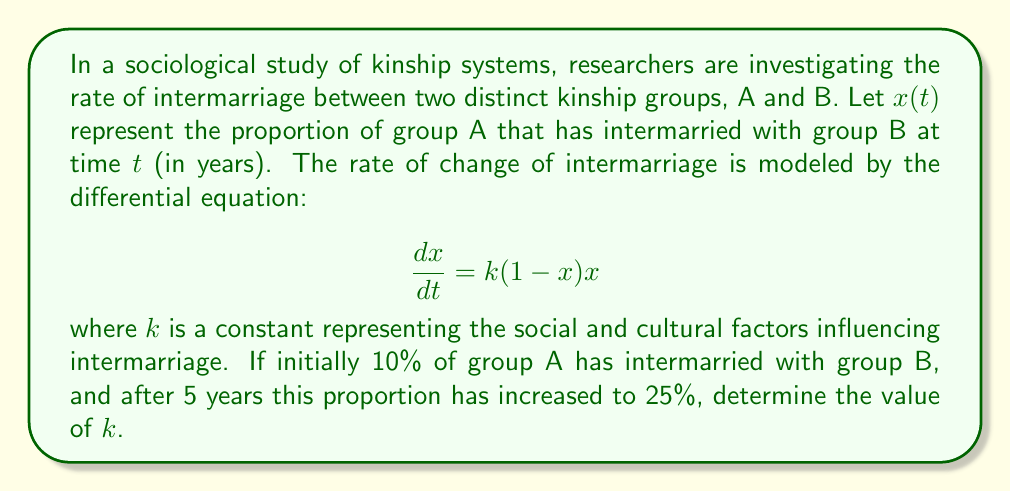Help me with this question. To solve this problem, we need to follow these steps:

1) First, we recognize this as a separable first-order differential equation.

2) We can separate the variables and integrate both sides:

   $$\int \frac{dx}{(1-x)x} = \int k dt$$

3) The left side can be integrated using partial fractions:

   $$\int (\frac{1}{x} + \frac{1}{1-x}) dx = kt + C$$

4) Integrating, we get:

   $$\ln|\frac{x}{1-x}| = kt + C$$

5) We can write this in the form of a logistic function:

   $$x = \frac{1}{1 + Ae^{-kt}}$$

   where $A$ is a constant.

6) Now we use the initial condition: at $t=0$, $x=0.1$

   $$0.1 = \frac{1}{1 + A}$$
   $$A = 9$$

7) We can now use the second condition: at $t=5$, $x=0.25$

   $$0.25 = \frac{1}{1 + 9e^{-5k}}$$

8) Solving this equation for $k$:

   $$9e^{-5k} = 3$$
   $$e^{-5k} = \frac{1}{3}$$
   $$-5k = \ln(\frac{1}{3})$$
   $$k = -\frac{1}{5}\ln(\frac{1}{3}) = \frac{1}{5}\ln(3)$$
Answer: $k = \frac{1}{5}\ln(3) \approx 0.2197$ per year 